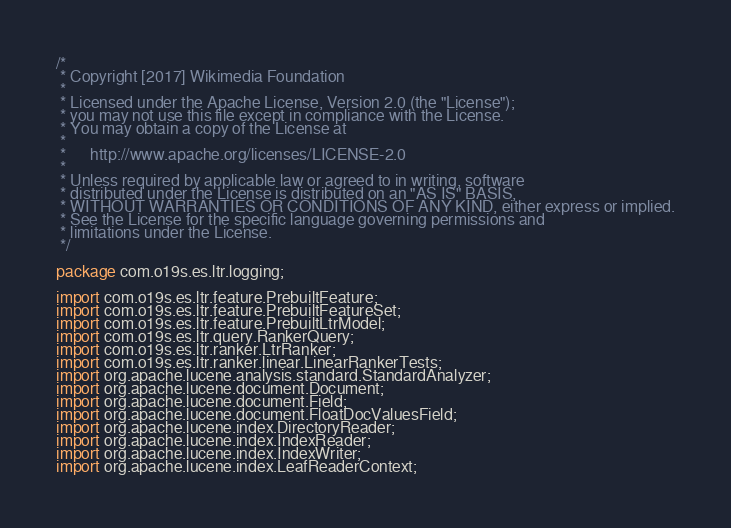<code> <loc_0><loc_0><loc_500><loc_500><_Java_>/*
 * Copyright [2017] Wikimedia Foundation
 *
 * Licensed under the Apache License, Version 2.0 (the "License");
 * you may not use this file except in compliance with the License.
 * You may obtain a copy of the License at
 *
 *      http://www.apache.org/licenses/LICENSE-2.0
 *
 * Unless required by applicable law or agreed to in writing, software
 * distributed under the License is distributed on an "AS IS" BASIS,
 * WITHOUT WARRANTIES OR CONDITIONS OF ANY KIND, either express or implied.
 * See the License for the specific language governing permissions and
 * limitations under the License.
 */

package com.o19s.es.ltr.logging;

import com.o19s.es.ltr.feature.PrebuiltFeature;
import com.o19s.es.ltr.feature.PrebuiltFeatureSet;
import com.o19s.es.ltr.feature.PrebuiltLtrModel;
import com.o19s.es.ltr.query.RankerQuery;
import com.o19s.es.ltr.ranker.LtrRanker;
import com.o19s.es.ltr.ranker.linear.LinearRankerTests;
import org.apache.lucene.analysis.standard.StandardAnalyzer;
import org.apache.lucene.document.Document;
import org.apache.lucene.document.Field;
import org.apache.lucene.document.FloatDocValuesField;
import org.apache.lucene.index.DirectoryReader;
import org.apache.lucene.index.IndexReader;
import org.apache.lucene.index.IndexWriter;
import org.apache.lucene.index.LeafReaderContext;</code> 